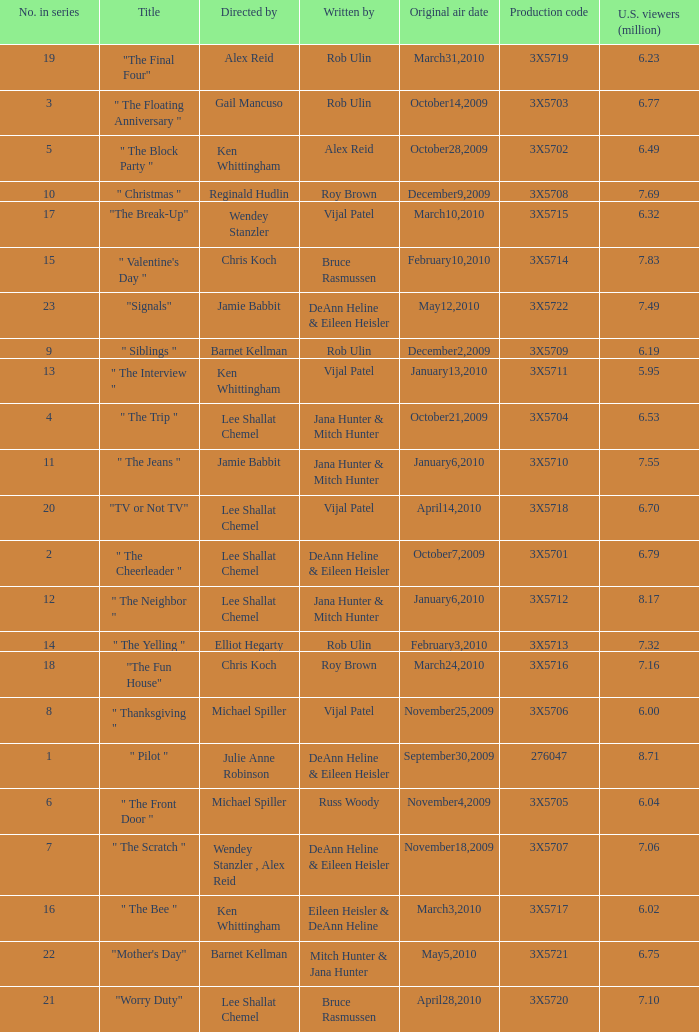What is the title of the episode Alex Reid directed? "The Final Four". 